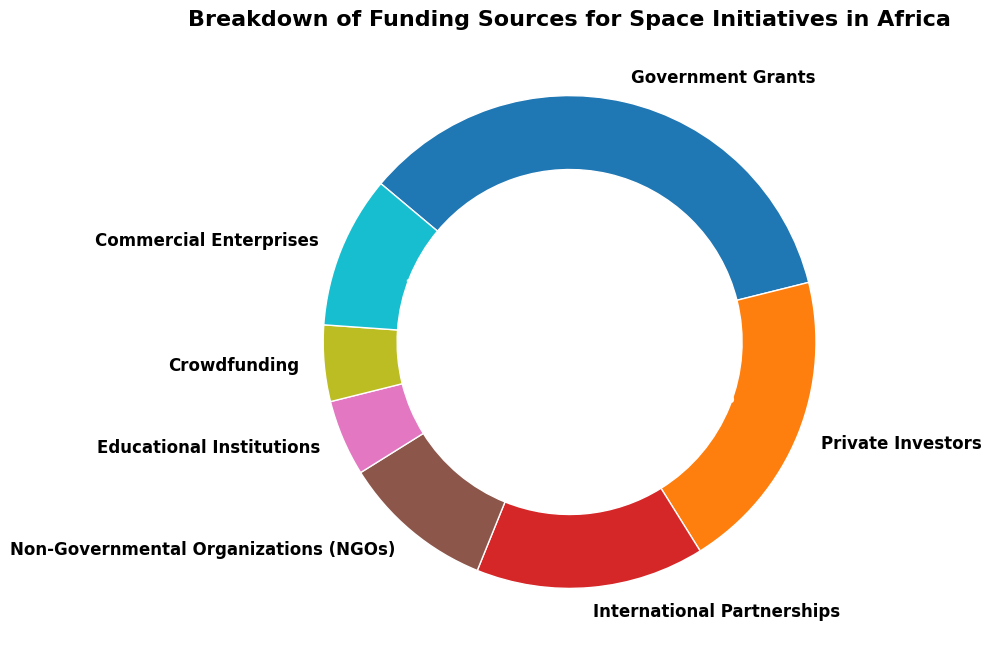Which funding source contributes the largest percentage to space initiatives in Africa? The segment labeled "Government Grants" has the largest portion of the ring chart, with a percentage of 35%. Therefore, Government Grants contribute the largest percentage.
Answer: Government Grants What is the combined percentage of funding from Commercial Enterprises and NGOs? The segments labeled "Commercial Enterprises" and "Non-Governmental Organizations (NGOs)" have percentages of 10% each. Adding these together, 10% + 10% = 20%.
Answer: 20% Which funding source contributes the least to space initiatives in Africa? The segments labeled "Educational Institutions" and "Crowdfunding" both have the smallest portions, each with a percentage of 5%. Therefore, these two funding sources contribute the least.
Answer: Educational Institutions and Crowdfunding How much more does the government grant contribute compared to private investors? The segment labeled "Government Grants" has 35%, and "Private Investors" has 20%. The difference is 35% - 20% = 15%.
Answer: 15% What is the total percentage of funding from sources other than government grants and private investors? The funding sources other than government grants and private investors are International Partnerships (15%), Non-Governmental Organizations (10%), Educational Institutions (5%), Crowdfunding (5%), and Commercial Enterprises (10%). Adding these percentages together, 15% + 10% + 5% + 5% + 10% = 45%.
Answer: 45% Are the contributions from International Partnerships and Commercial Enterprises equal? The ring chart shows separate segments where International Partnerships contribute 15% and Commercial Enterprises contribute 10%. Hence, they are not equal.
Answer: No How do the contributions from private investors compare to those from international partnerships? The segment labeled "Private Investors" shows a contribution of 20%, whereas "International Partnerships" has a segment of 15%. Therefore, private investors contribute more.
Answer: Private Investors contribute more What is the total percentage contributed by Private Investors, International Partnerships, and NGOs combined? The contributions are as follows: Private Investors (20%), International Partnerships (15%), and Non-Governmental Organizations (10%). Adding them together, 20% + 15% + 10% = 45%.
Answer: 45% If funding from educational institutions doubled, what would be their new percentage? The current funding from Educational Institutions is 5%. If it doubled, it would be 5% * 2 = 10%.
Answer: 10% Which funding sources have equal percentages, and what is the percentage they each contribute? The segments labeled "Educational Institutions" and "Crowdfunding" each have a percentage of 5%. Therefore, they contribute equally.
Answer: Educational Institutions and Crowdfunding, 5% 